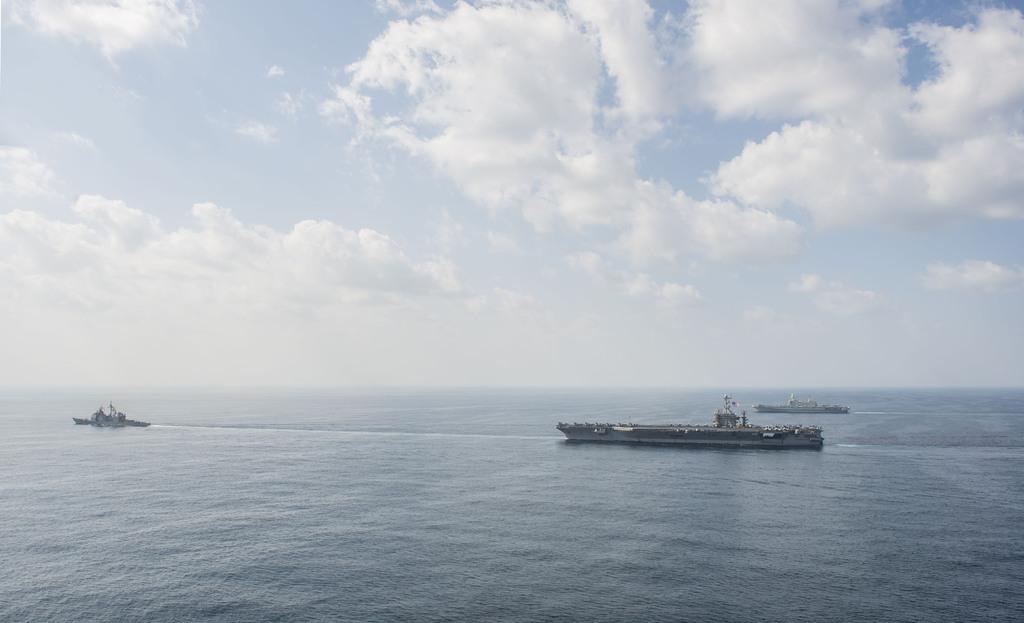How many ships can be seen in the image? There are 3 ships in the image. What are the ships doing in the image? The ships are moving in the water. What is the condition of the sky in the image? The sky is cloudy in the image. What type of watch is the captain wearing on the voyage? There is no watch or captain present in the image; it only shows 3 ships moving in the water with a cloudy sky. 